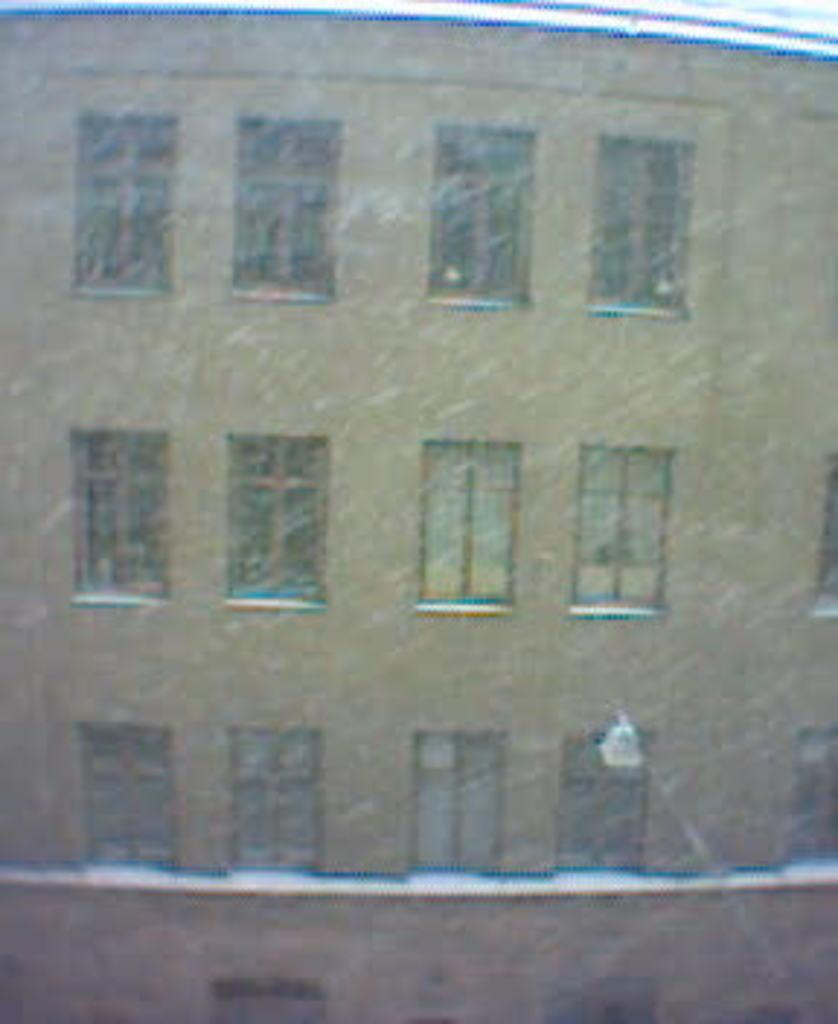What type of structure is visible in the image? There is a building with windows in the image. Is there anything attached to the building? Yes, there is an object attached to the building. What can be seen on the top of the image? There are two objects that look like pipes on the top of the image. How would you describe the quality of the image? The image is blurred. How many chairs are visible in the image? There are no chairs present in the image. Is the building in the image used for sleeping? The image does not provide information about the purpose of the building, so it cannot be determined if it is used for sleeping. 